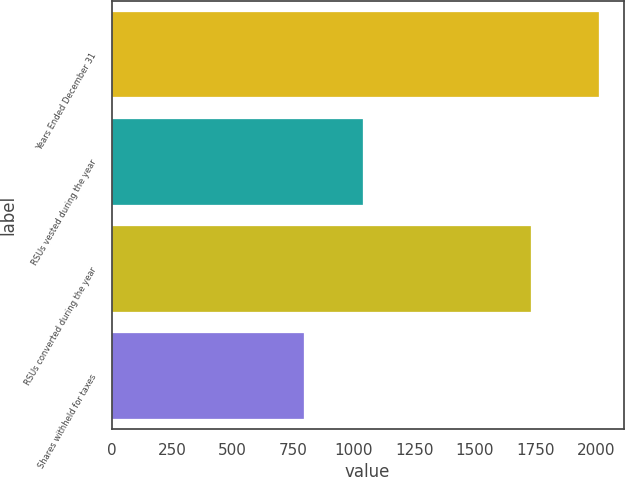<chart> <loc_0><loc_0><loc_500><loc_500><bar_chart><fcel>Years Ended December 31<fcel>RSUs vested during the year<fcel>RSUs converted during the year<fcel>Shares withheld for taxes<nl><fcel>2014<fcel>1037<fcel>1734<fcel>796<nl></chart> 